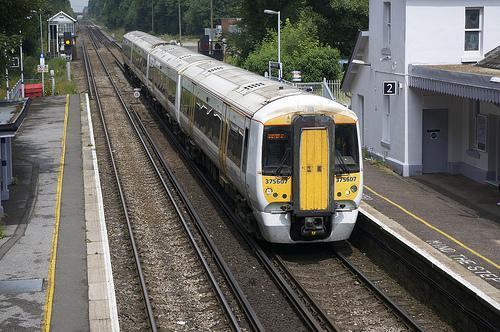How many trains?
Give a very brief answer. 1. 